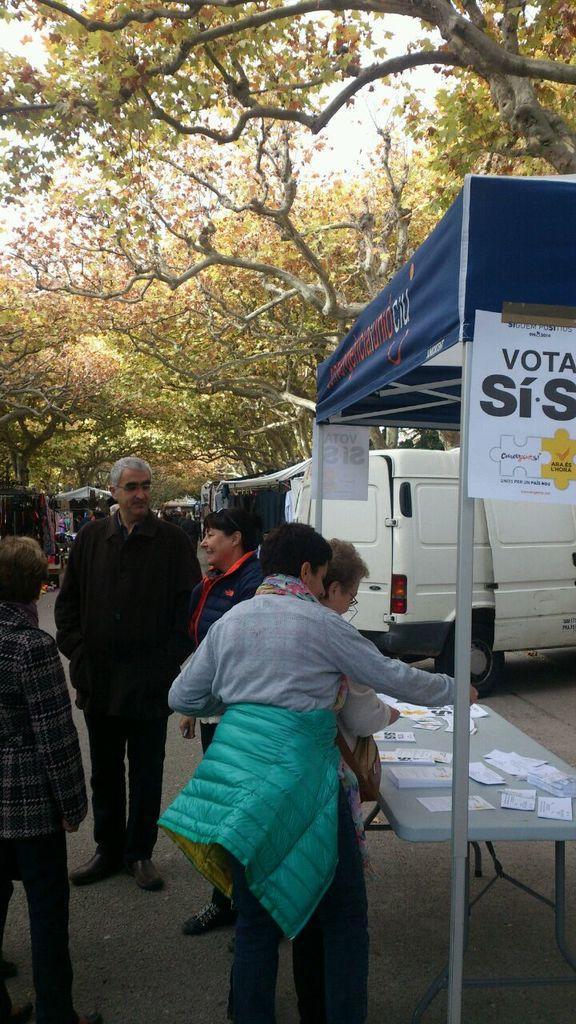In one or two sentences, can you explain what this image depicts? In the image on the left side there are few people standing. And on the right side of the image there is a table with papers. And also there is a tent with rods and also there are posters with some text on it. In the background there are vehicles and also there are tents. At the top of the image there are trees. 